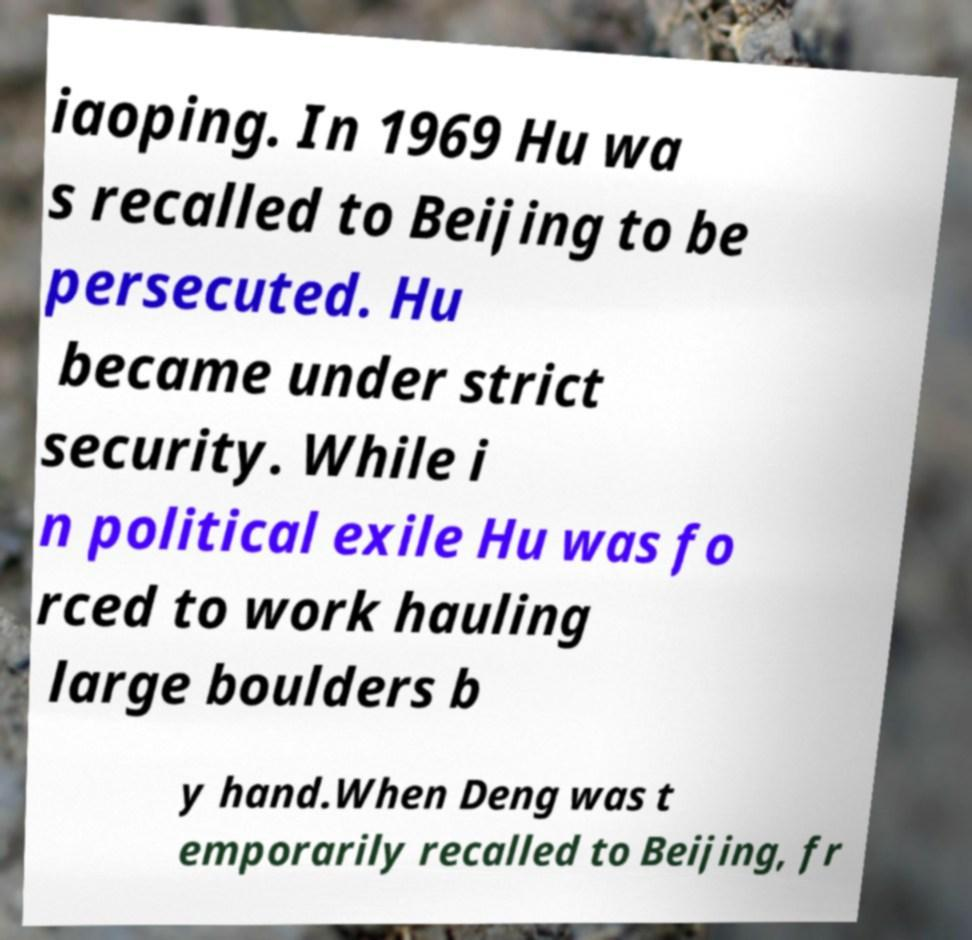What messages or text are displayed in this image? I need them in a readable, typed format. iaoping. In 1969 Hu wa s recalled to Beijing to be persecuted. Hu became under strict security. While i n political exile Hu was fo rced to work hauling large boulders b y hand.When Deng was t emporarily recalled to Beijing, fr 